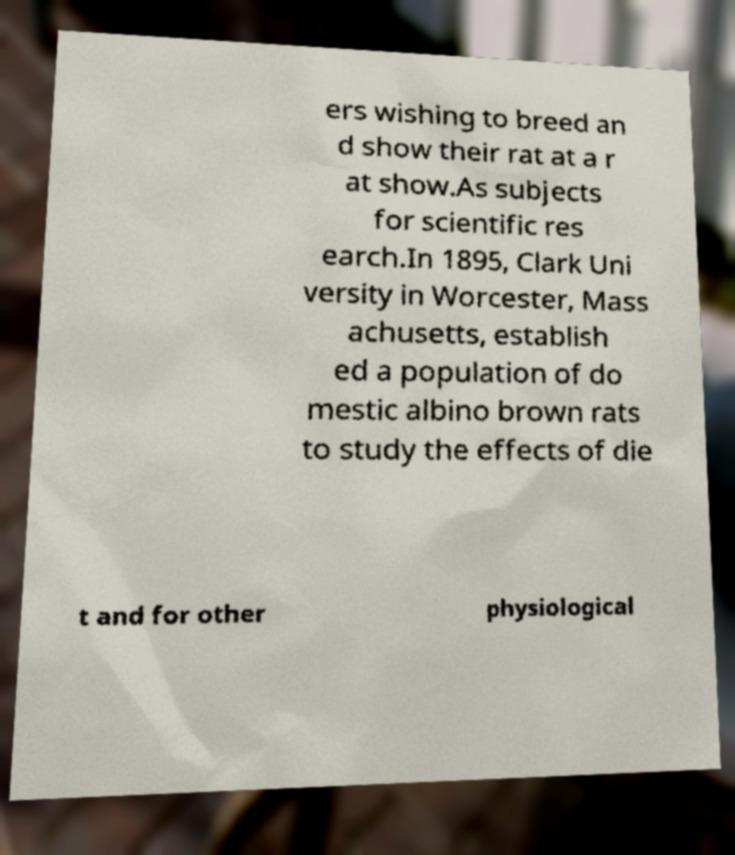For documentation purposes, I need the text within this image transcribed. Could you provide that? ers wishing to breed an d show their rat at a r at show.As subjects for scientific res earch.In 1895, Clark Uni versity in Worcester, Mass achusetts, establish ed a population of do mestic albino brown rats to study the effects of die t and for other physiological 